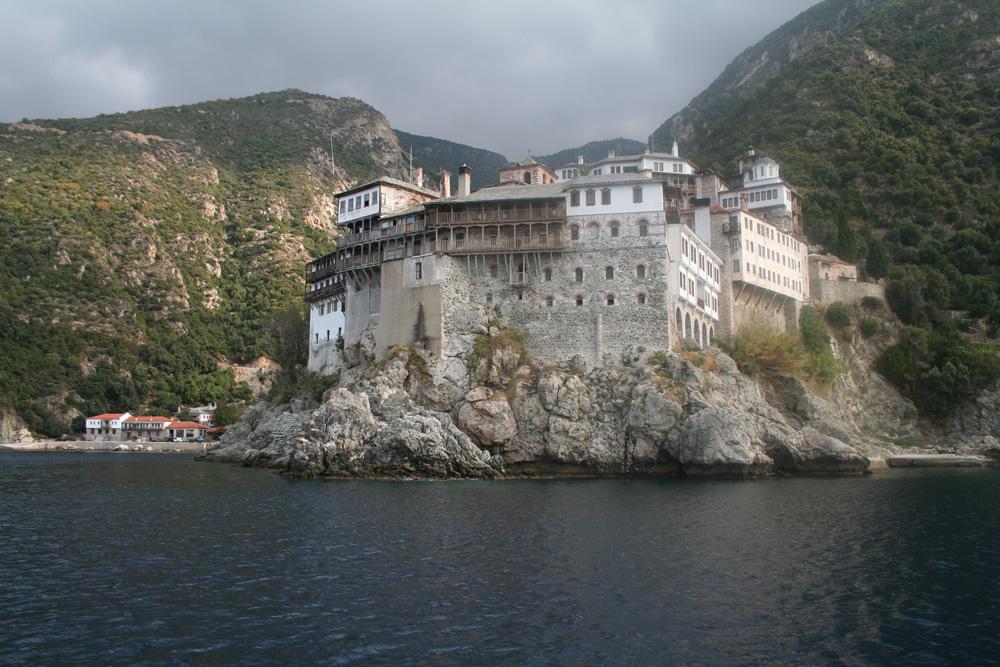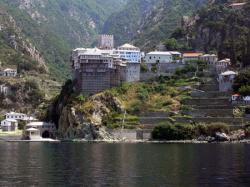The first image is the image on the left, the second image is the image on the right. Given the left and right images, does the statement "Only one of the images show a body of water." hold true? Answer yes or no. No. The first image is the image on the left, the second image is the image on the right. Assess this claim about the two images: "there is water in the image on the right". Correct or not? Answer yes or no. Yes. 